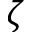Convert formula to latex. <formula><loc_0><loc_0><loc_500><loc_500>\zeta</formula> 